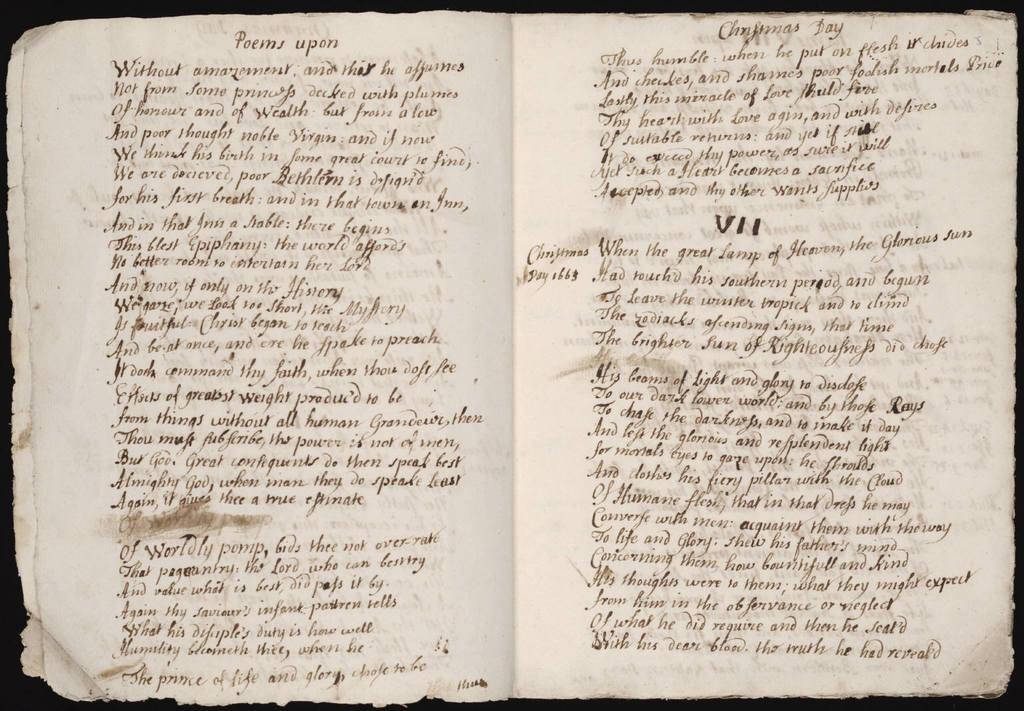What is the top line of the page on the left?
Your response must be concise. Poems upon. 